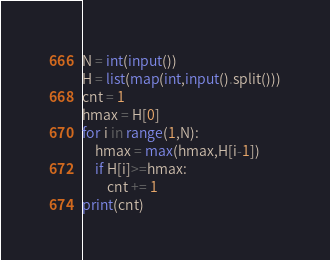Convert code to text. <code><loc_0><loc_0><loc_500><loc_500><_Python_>N = int(input())
H = list(map(int,input().split()))
cnt = 1
hmax = H[0]
for i in range(1,N):
    hmax = max(hmax,H[i-1])
    if H[i]>=hmax:
        cnt += 1
print(cnt)        </code> 